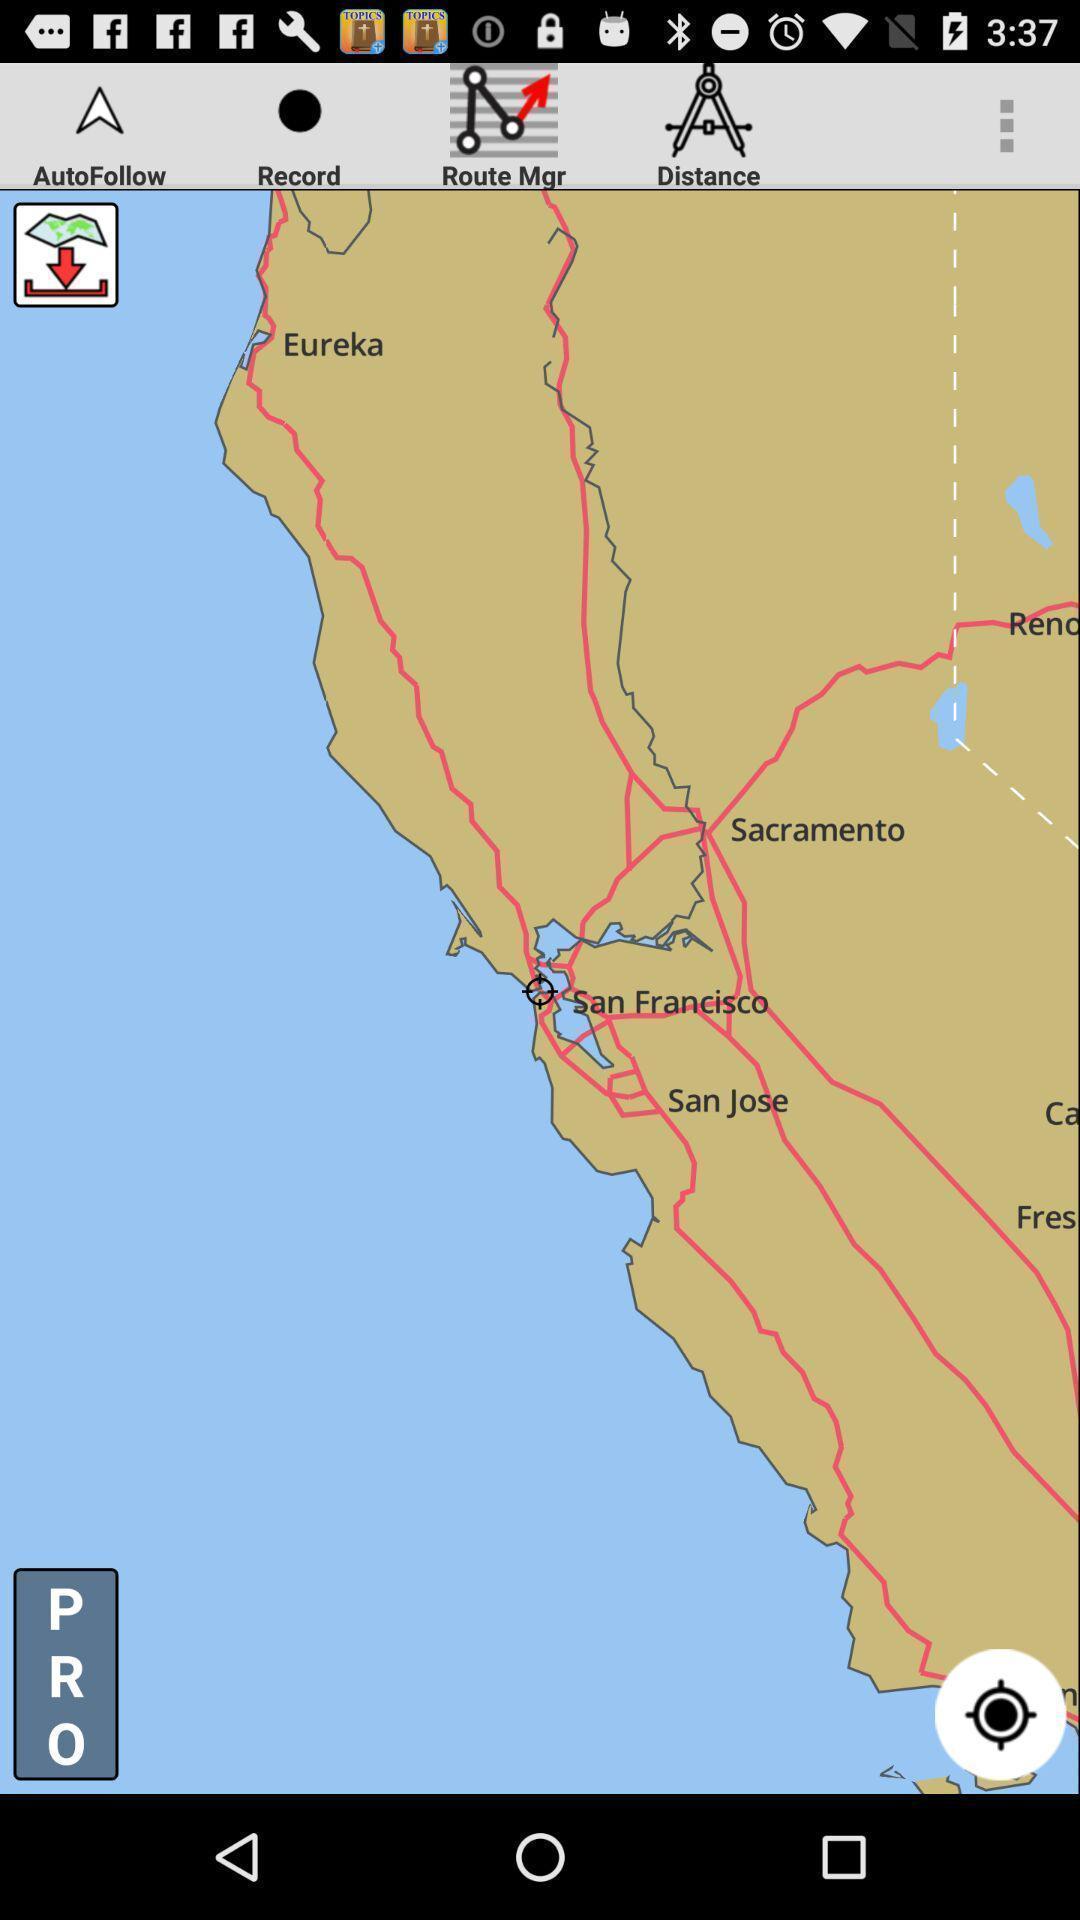Please provide a description for this image. Screen displaying a map view with multiple controls. 